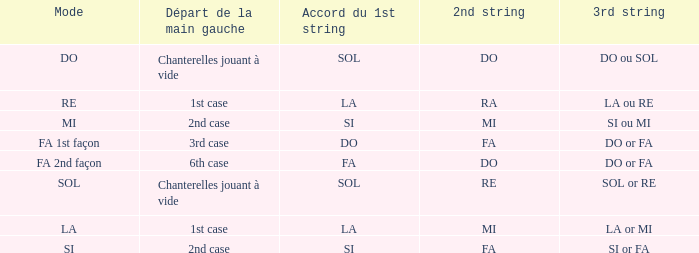For the 2nd string of Do and an Accord du 1st string of FA what is the Depart de la main gauche? 6th case. 